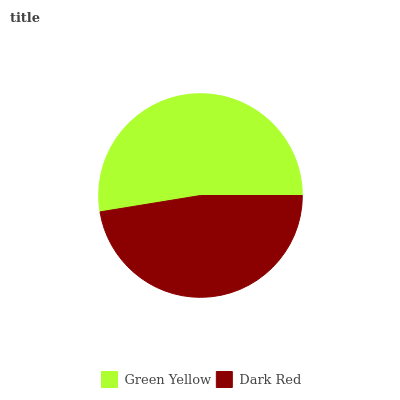Is Dark Red the minimum?
Answer yes or no. Yes. Is Green Yellow the maximum?
Answer yes or no. Yes. Is Dark Red the maximum?
Answer yes or no. No. Is Green Yellow greater than Dark Red?
Answer yes or no. Yes. Is Dark Red less than Green Yellow?
Answer yes or no. Yes. Is Dark Red greater than Green Yellow?
Answer yes or no. No. Is Green Yellow less than Dark Red?
Answer yes or no. No. Is Green Yellow the high median?
Answer yes or no. Yes. Is Dark Red the low median?
Answer yes or no. Yes. Is Dark Red the high median?
Answer yes or no. No. Is Green Yellow the low median?
Answer yes or no. No. 